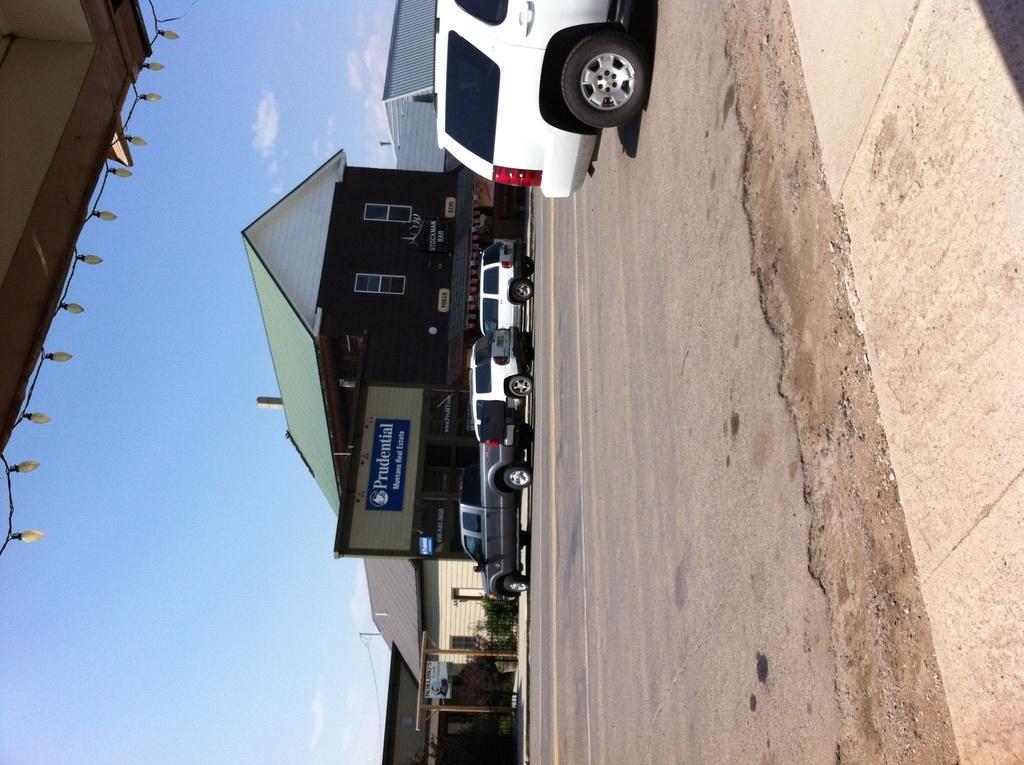In one or two sentences, can you explain what this image depicts? In this image I can see few vehicles on the road, at left I can see a building in green and brown color, at top sky is in white and blue color. 